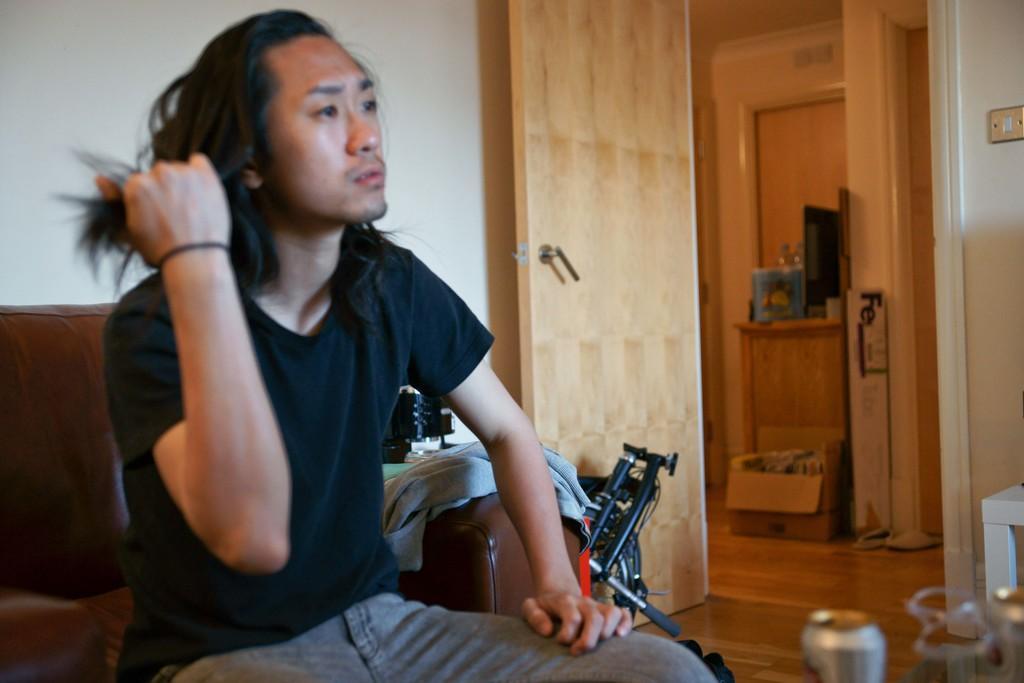Describe this image in one or two sentences. In this picture we can see a man is sitting on a sofa, at the right bottom there is a tin, we can see a cloth and a wheelchair beside this man, in the background there is a door, a cardboard box and a table, there is a monitor and two bottles present on the table, on the left side there is a wall. 